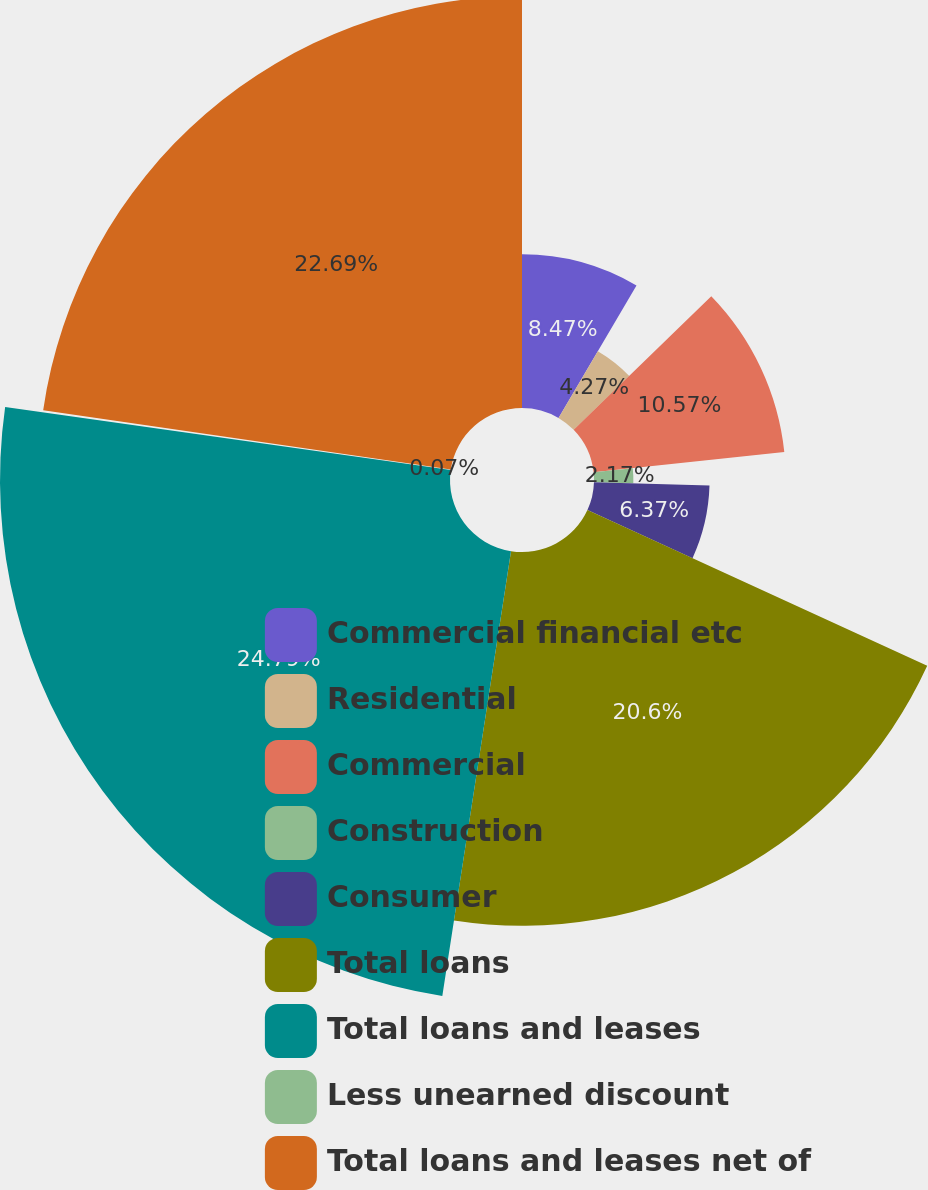<chart> <loc_0><loc_0><loc_500><loc_500><pie_chart><fcel>Commercial financial etc<fcel>Residential<fcel>Commercial<fcel>Construction<fcel>Consumer<fcel>Total loans<fcel>Total loans and leases<fcel>Less unearned discount<fcel>Total loans and leases net of<nl><fcel>8.47%<fcel>4.27%<fcel>10.57%<fcel>2.17%<fcel>6.37%<fcel>20.6%<fcel>24.8%<fcel>0.07%<fcel>22.7%<nl></chart> 